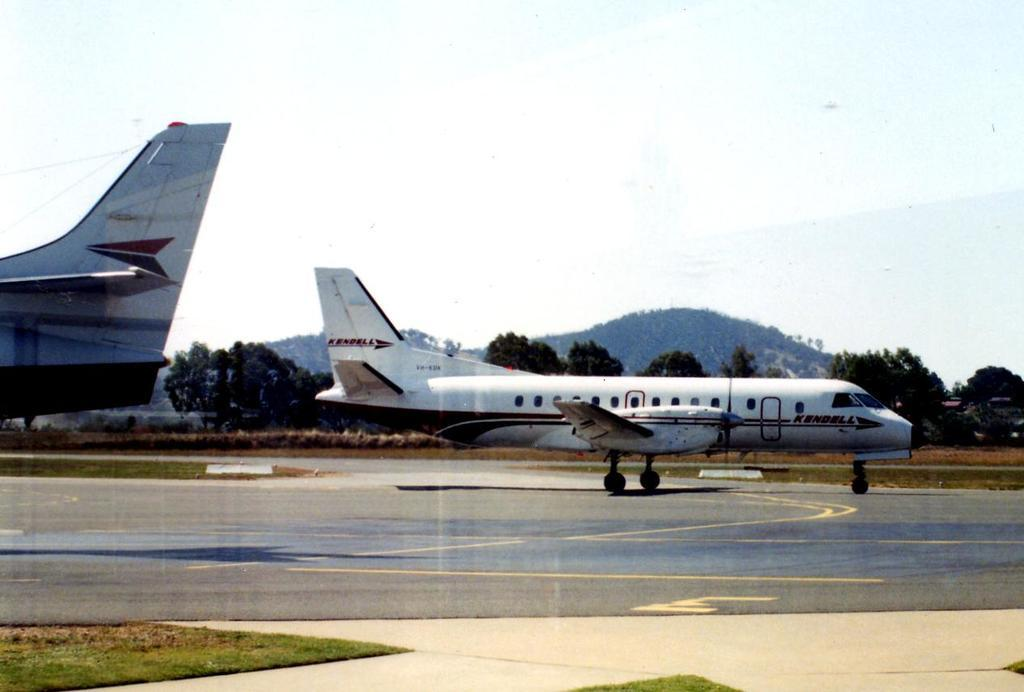<image>
Give a short and clear explanation of the subsequent image. A large prop airplane with the logo "kendell" is on the runway behind another large airplane. 